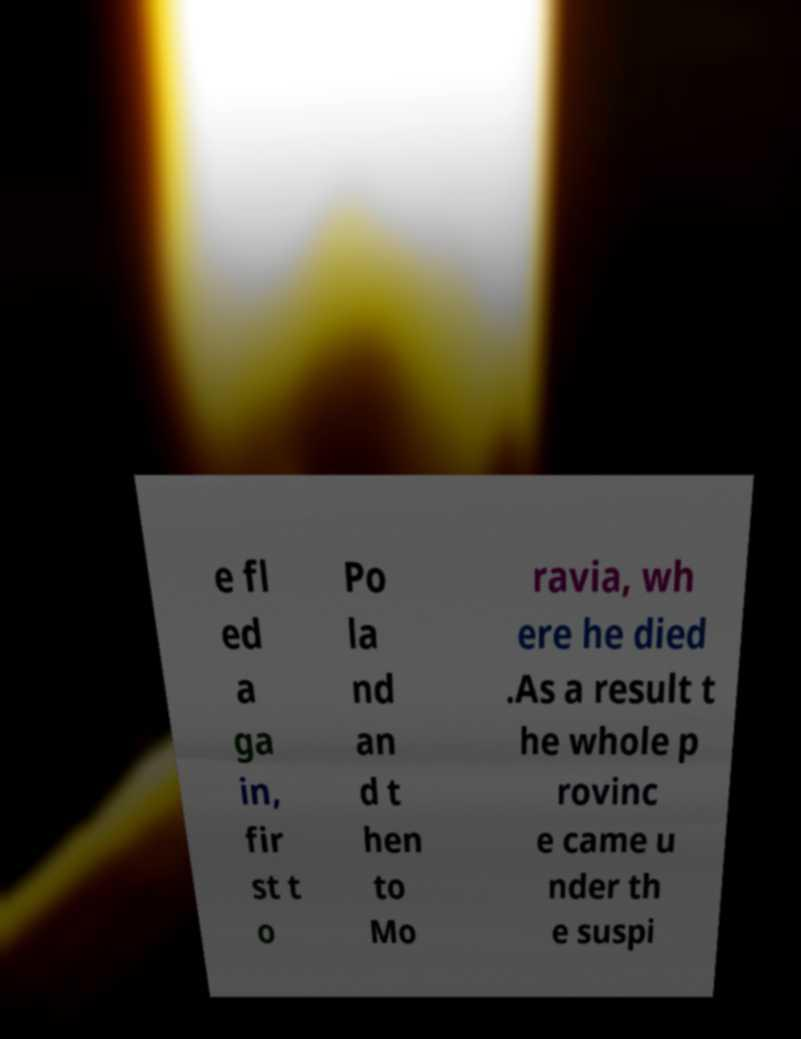Could you extract and type out the text from this image? e fl ed a ga in, fir st t o Po la nd an d t hen to Mo ravia, wh ere he died .As a result t he whole p rovinc e came u nder th e suspi 